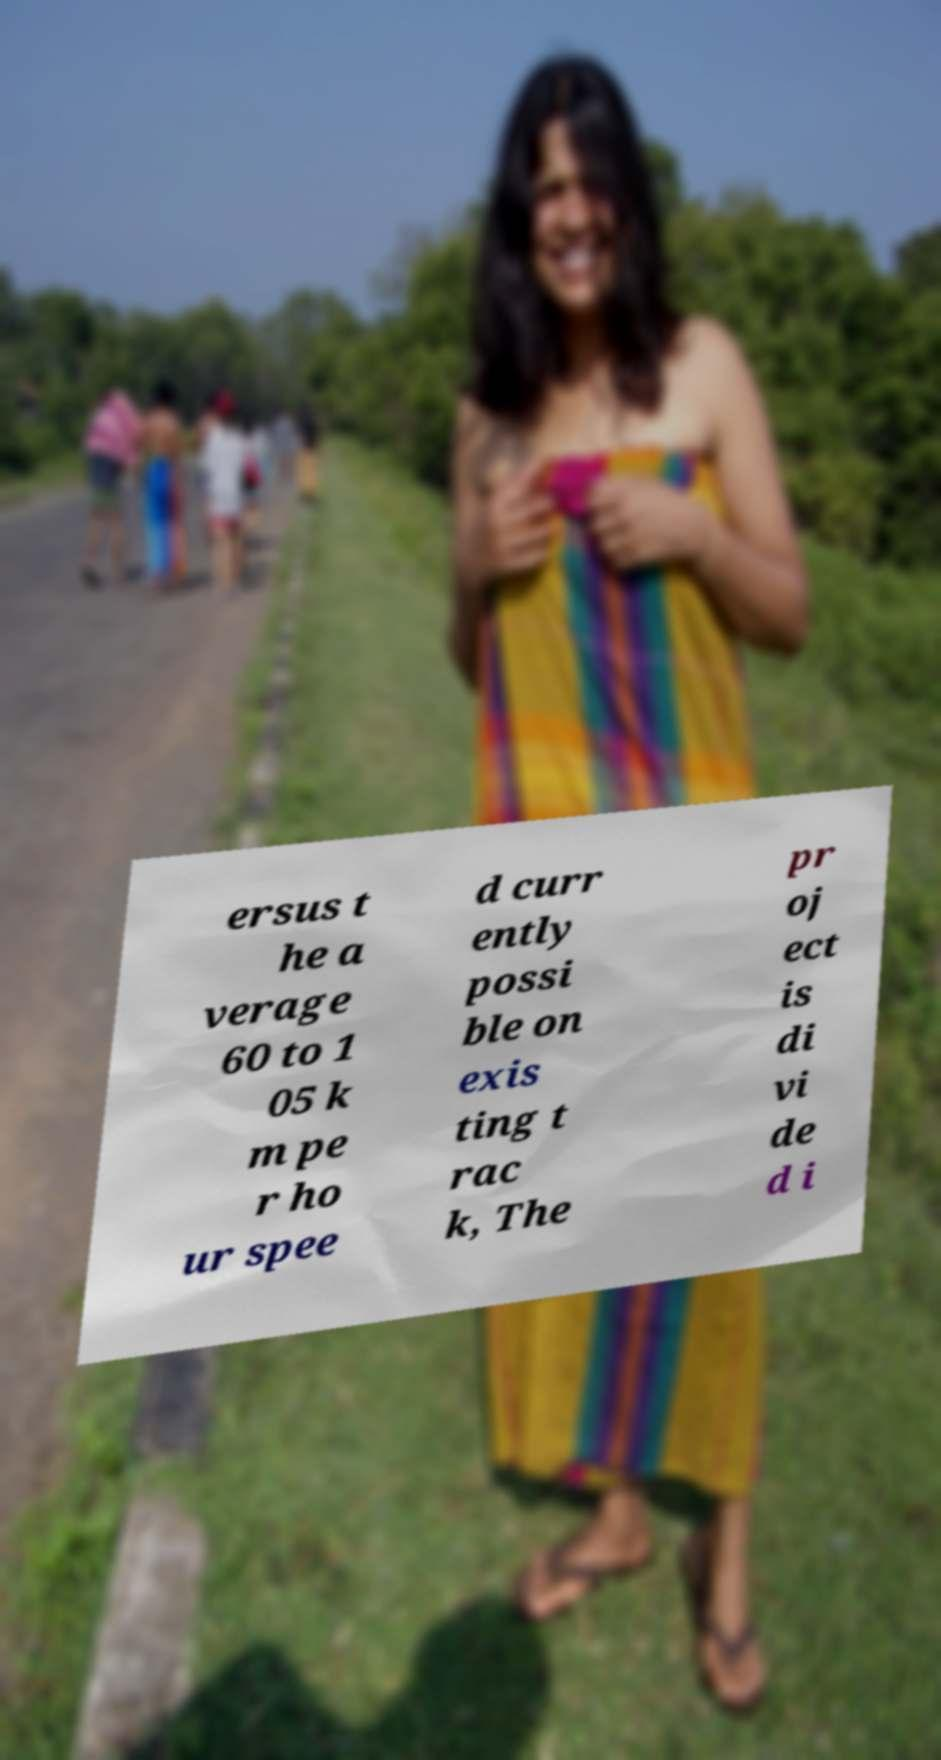Can you accurately transcribe the text from the provided image for me? ersus t he a verage 60 to 1 05 k m pe r ho ur spee d curr ently possi ble on exis ting t rac k, The pr oj ect is di vi de d i 